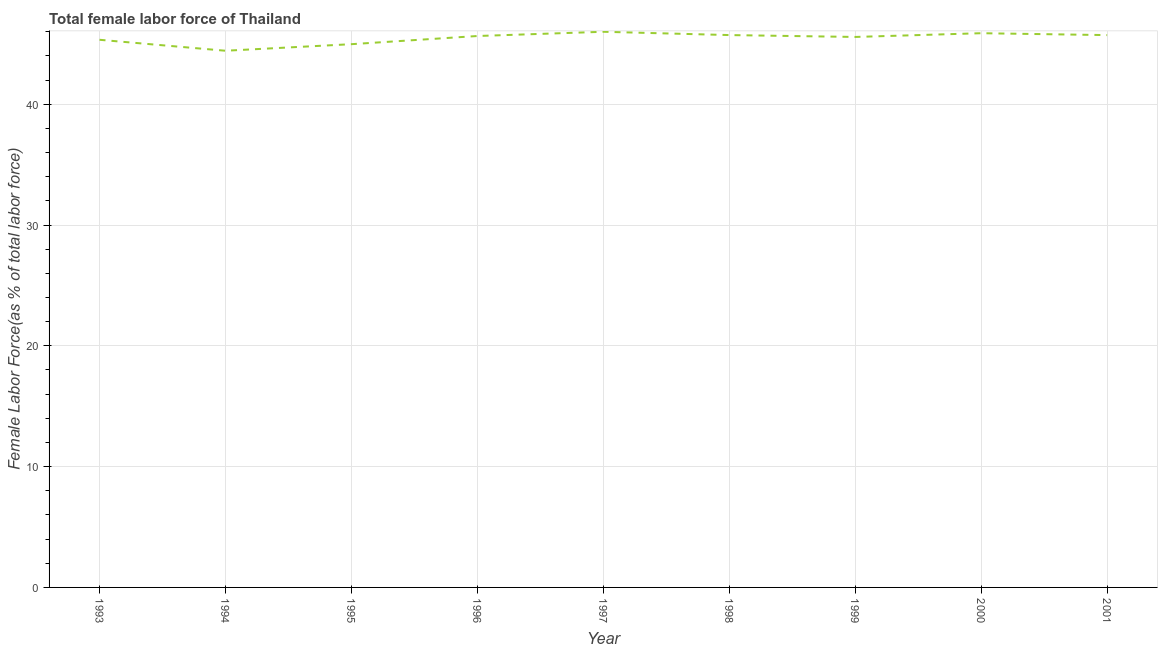What is the total female labor force in 1999?
Give a very brief answer. 45.57. Across all years, what is the maximum total female labor force?
Make the answer very short. 46. Across all years, what is the minimum total female labor force?
Your answer should be very brief. 44.43. In which year was the total female labor force minimum?
Offer a terse response. 1994. What is the sum of the total female labor force?
Make the answer very short. 409.27. What is the difference between the total female labor force in 1994 and 2001?
Offer a very short reply. -1.29. What is the average total female labor force per year?
Offer a terse response. 45.47. What is the median total female labor force?
Offer a very short reply. 45.65. Do a majority of the years between 1998 and 1995 (inclusive) have total female labor force greater than 14 %?
Provide a succinct answer. Yes. What is the ratio of the total female labor force in 1994 to that in 1998?
Your response must be concise. 0.97. Is the difference between the total female labor force in 1993 and 1994 greater than the difference between any two years?
Give a very brief answer. No. What is the difference between the highest and the second highest total female labor force?
Your answer should be compact. 0.12. What is the difference between the highest and the lowest total female labor force?
Your response must be concise. 1.57. In how many years, is the total female labor force greater than the average total female labor force taken over all years?
Keep it short and to the point. 6. How many years are there in the graph?
Provide a succinct answer. 9. Are the values on the major ticks of Y-axis written in scientific E-notation?
Ensure brevity in your answer.  No. Does the graph contain any zero values?
Make the answer very short. No. Does the graph contain grids?
Offer a terse response. Yes. What is the title of the graph?
Offer a terse response. Total female labor force of Thailand. What is the label or title of the X-axis?
Provide a short and direct response. Year. What is the label or title of the Y-axis?
Your answer should be very brief. Female Labor Force(as % of total labor force). What is the Female Labor Force(as % of total labor force) of 1993?
Make the answer very short. 45.33. What is the Female Labor Force(as % of total labor force) of 1994?
Give a very brief answer. 44.43. What is the Female Labor Force(as % of total labor force) of 1995?
Your answer should be compact. 44.97. What is the Female Labor Force(as % of total labor force) of 1996?
Provide a succinct answer. 45.65. What is the Female Labor Force(as % of total labor force) in 1997?
Your answer should be very brief. 46. What is the Female Labor Force(as % of total labor force) in 1998?
Offer a terse response. 45.72. What is the Female Labor Force(as % of total labor force) in 1999?
Provide a succinct answer. 45.57. What is the Female Labor Force(as % of total labor force) of 2000?
Give a very brief answer. 45.88. What is the Female Labor Force(as % of total labor force) of 2001?
Ensure brevity in your answer.  45.72. What is the difference between the Female Labor Force(as % of total labor force) in 1993 and 1994?
Your response must be concise. 0.91. What is the difference between the Female Labor Force(as % of total labor force) in 1993 and 1995?
Your answer should be very brief. 0.36. What is the difference between the Female Labor Force(as % of total labor force) in 1993 and 1996?
Your response must be concise. -0.31. What is the difference between the Female Labor Force(as % of total labor force) in 1993 and 1997?
Keep it short and to the point. -0.66. What is the difference between the Female Labor Force(as % of total labor force) in 1993 and 1998?
Provide a short and direct response. -0.39. What is the difference between the Female Labor Force(as % of total labor force) in 1993 and 1999?
Keep it short and to the point. -0.23. What is the difference between the Female Labor Force(as % of total labor force) in 1993 and 2000?
Offer a terse response. -0.54. What is the difference between the Female Labor Force(as % of total labor force) in 1993 and 2001?
Give a very brief answer. -0.39. What is the difference between the Female Labor Force(as % of total labor force) in 1994 and 1995?
Offer a very short reply. -0.54. What is the difference between the Female Labor Force(as % of total labor force) in 1994 and 1996?
Your answer should be very brief. -1.22. What is the difference between the Female Labor Force(as % of total labor force) in 1994 and 1997?
Offer a terse response. -1.57. What is the difference between the Female Labor Force(as % of total labor force) in 1994 and 1998?
Your response must be concise. -1.3. What is the difference between the Female Labor Force(as % of total labor force) in 1994 and 1999?
Provide a succinct answer. -1.14. What is the difference between the Female Labor Force(as % of total labor force) in 1994 and 2000?
Your response must be concise. -1.45. What is the difference between the Female Labor Force(as % of total labor force) in 1994 and 2001?
Offer a terse response. -1.29. What is the difference between the Female Labor Force(as % of total labor force) in 1995 and 1996?
Provide a short and direct response. -0.68. What is the difference between the Female Labor Force(as % of total labor force) in 1995 and 1997?
Your answer should be very brief. -1.03. What is the difference between the Female Labor Force(as % of total labor force) in 1995 and 1998?
Keep it short and to the point. -0.75. What is the difference between the Female Labor Force(as % of total labor force) in 1995 and 1999?
Offer a terse response. -0.6. What is the difference between the Female Labor Force(as % of total labor force) in 1995 and 2000?
Offer a very short reply. -0.91. What is the difference between the Female Labor Force(as % of total labor force) in 1995 and 2001?
Ensure brevity in your answer.  -0.75. What is the difference between the Female Labor Force(as % of total labor force) in 1996 and 1997?
Your response must be concise. -0.35. What is the difference between the Female Labor Force(as % of total labor force) in 1996 and 1998?
Ensure brevity in your answer.  -0.08. What is the difference between the Female Labor Force(as % of total labor force) in 1996 and 1999?
Your response must be concise. 0.08. What is the difference between the Female Labor Force(as % of total labor force) in 1996 and 2000?
Your answer should be very brief. -0.23. What is the difference between the Female Labor Force(as % of total labor force) in 1996 and 2001?
Provide a succinct answer. -0.07. What is the difference between the Female Labor Force(as % of total labor force) in 1997 and 1998?
Make the answer very short. 0.27. What is the difference between the Female Labor Force(as % of total labor force) in 1997 and 1999?
Offer a very short reply. 0.43. What is the difference between the Female Labor Force(as % of total labor force) in 1997 and 2000?
Ensure brevity in your answer.  0.12. What is the difference between the Female Labor Force(as % of total labor force) in 1997 and 2001?
Provide a short and direct response. 0.28. What is the difference between the Female Labor Force(as % of total labor force) in 1998 and 1999?
Provide a short and direct response. 0.16. What is the difference between the Female Labor Force(as % of total labor force) in 1998 and 2000?
Give a very brief answer. -0.15. What is the difference between the Female Labor Force(as % of total labor force) in 1998 and 2001?
Your answer should be very brief. 0. What is the difference between the Female Labor Force(as % of total labor force) in 1999 and 2000?
Make the answer very short. -0.31. What is the difference between the Female Labor Force(as % of total labor force) in 1999 and 2001?
Provide a succinct answer. -0.15. What is the difference between the Female Labor Force(as % of total labor force) in 2000 and 2001?
Offer a very short reply. 0.16. What is the ratio of the Female Labor Force(as % of total labor force) in 1993 to that in 1994?
Ensure brevity in your answer.  1.02. What is the ratio of the Female Labor Force(as % of total labor force) in 1993 to that in 1995?
Give a very brief answer. 1.01. What is the ratio of the Female Labor Force(as % of total labor force) in 1993 to that in 1996?
Your answer should be compact. 0.99. What is the ratio of the Female Labor Force(as % of total labor force) in 1993 to that in 1997?
Offer a terse response. 0.99. What is the ratio of the Female Labor Force(as % of total labor force) in 1993 to that in 1999?
Offer a very short reply. 0.99. What is the ratio of the Female Labor Force(as % of total labor force) in 1993 to that in 2000?
Your response must be concise. 0.99. What is the ratio of the Female Labor Force(as % of total labor force) in 1994 to that in 1997?
Ensure brevity in your answer.  0.97. What is the ratio of the Female Labor Force(as % of total labor force) in 1995 to that in 1996?
Ensure brevity in your answer.  0.98. What is the ratio of the Female Labor Force(as % of total labor force) in 1995 to that in 1998?
Your response must be concise. 0.98. What is the ratio of the Female Labor Force(as % of total labor force) in 1995 to that in 2000?
Your response must be concise. 0.98. What is the ratio of the Female Labor Force(as % of total labor force) in 1996 to that in 1997?
Offer a very short reply. 0.99. What is the ratio of the Female Labor Force(as % of total labor force) in 1996 to that in 2000?
Your answer should be compact. 0.99. What is the ratio of the Female Labor Force(as % of total labor force) in 1996 to that in 2001?
Your answer should be very brief. 1. What is the ratio of the Female Labor Force(as % of total labor force) in 1997 to that in 2000?
Offer a very short reply. 1. What is the ratio of the Female Labor Force(as % of total labor force) in 1997 to that in 2001?
Ensure brevity in your answer.  1.01. What is the ratio of the Female Labor Force(as % of total labor force) in 1998 to that in 1999?
Provide a short and direct response. 1. What is the ratio of the Female Labor Force(as % of total labor force) in 1998 to that in 2001?
Your answer should be compact. 1. What is the ratio of the Female Labor Force(as % of total labor force) in 2000 to that in 2001?
Give a very brief answer. 1. 